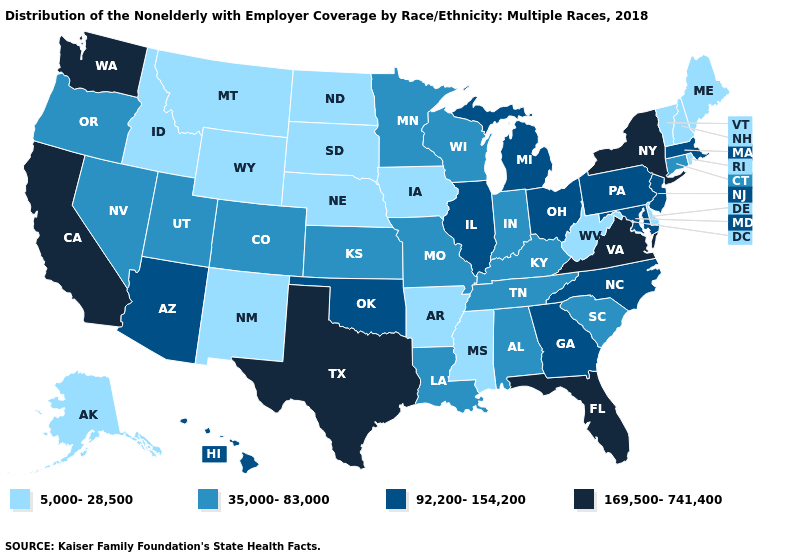What is the lowest value in the Northeast?
Keep it brief. 5,000-28,500. Name the states that have a value in the range 169,500-741,400?
Keep it brief. California, Florida, New York, Texas, Virginia, Washington. What is the lowest value in states that border Utah?
Keep it brief. 5,000-28,500. Name the states that have a value in the range 35,000-83,000?
Be succinct. Alabama, Colorado, Connecticut, Indiana, Kansas, Kentucky, Louisiana, Minnesota, Missouri, Nevada, Oregon, South Carolina, Tennessee, Utah, Wisconsin. What is the value of Montana?
Write a very short answer. 5,000-28,500. Does Illinois have the lowest value in the USA?
Quick response, please. No. Name the states that have a value in the range 35,000-83,000?
Keep it brief. Alabama, Colorado, Connecticut, Indiana, Kansas, Kentucky, Louisiana, Minnesota, Missouri, Nevada, Oregon, South Carolina, Tennessee, Utah, Wisconsin. Among the states that border Illinois , which have the lowest value?
Give a very brief answer. Iowa. Does California have the highest value in the West?
Give a very brief answer. Yes. What is the value of Louisiana?
Short answer required. 35,000-83,000. What is the lowest value in states that border Iowa?
Short answer required. 5,000-28,500. Does the first symbol in the legend represent the smallest category?
Quick response, please. Yes. Does Florida have the highest value in the USA?
Quick response, please. Yes. Among the states that border New Hampshire , which have the lowest value?
Write a very short answer. Maine, Vermont. 